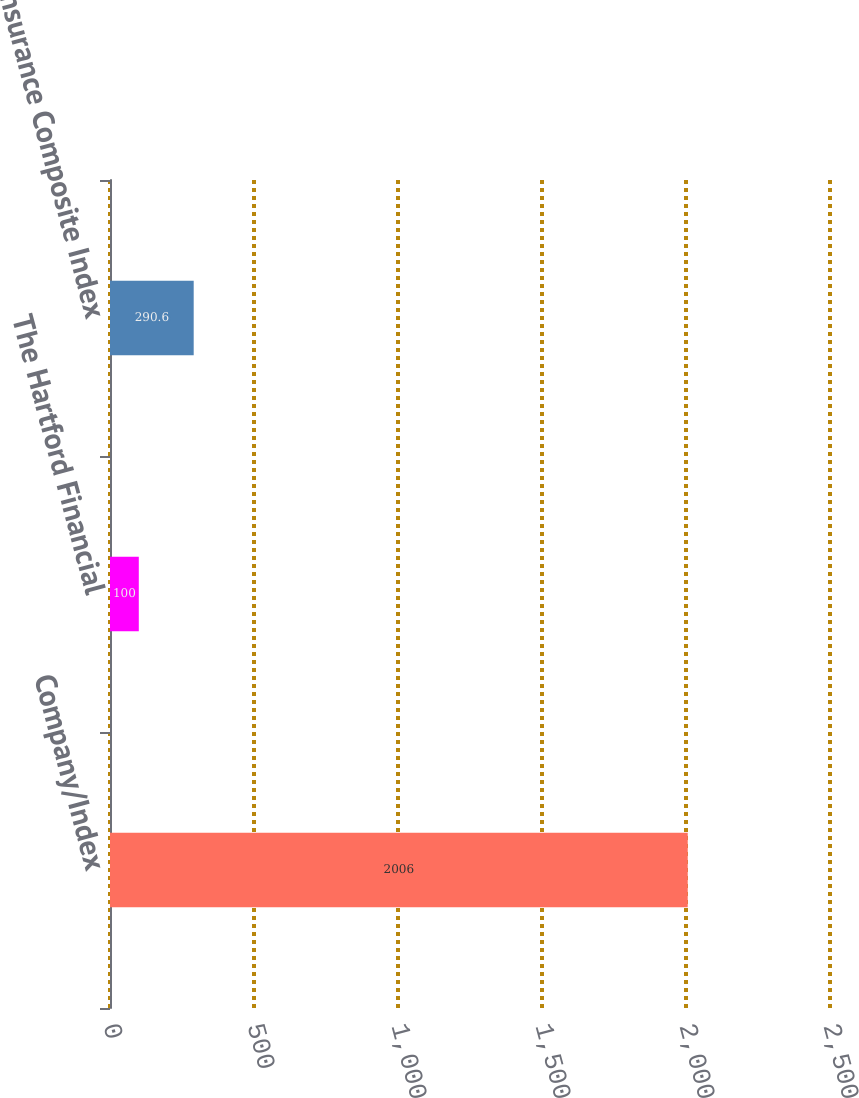Convert chart. <chart><loc_0><loc_0><loc_500><loc_500><bar_chart><fcel>Company/Index<fcel>The Hartford Financial<fcel>S&P Insurance Composite Index<nl><fcel>2006<fcel>100<fcel>290.6<nl></chart> 